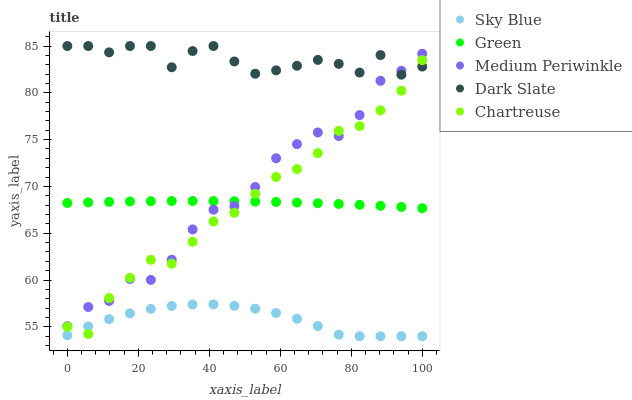Does Sky Blue have the minimum area under the curve?
Answer yes or no. Yes. Does Dark Slate have the maximum area under the curve?
Answer yes or no. Yes. Does Chartreuse have the minimum area under the curve?
Answer yes or no. No. Does Chartreuse have the maximum area under the curve?
Answer yes or no. No. Is Green the smoothest?
Answer yes or no. Yes. Is Dark Slate the roughest?
Answer yes or no. Yes. Is Chartreuse the smoothest?
Answer yes or no. No. Is Chartreuse the roughest?
Answer yes or no. No. Does Sky Blue have the lowest value?
Answer yes or no. Yes. Does Chartreuse have the lowest value?
Answer yes or no. No. Does Dark Slate have the highest value?
Answer yes or no. Yes. Does Chartreuse have the highest value?
Answer yes or no. No. Is Sky Blue less than Medium Periwinkle?
Answer yes or no. Yes. Is Medium Periwinkle greater than Sky Blue?
Answer yes or no. Yes. Does Chartreuse intersect Medium Periwinkle?
Answer yes or no. Yes. Is Chartreuse less than Medium Periwinkle?
Answer yes or no. No. Is Chartreuse greater than Medium Periwinkle?
Answer yes or no. No. Does Sky Blue intersect Medium Periwinkle?
Answer yes or no. No. 